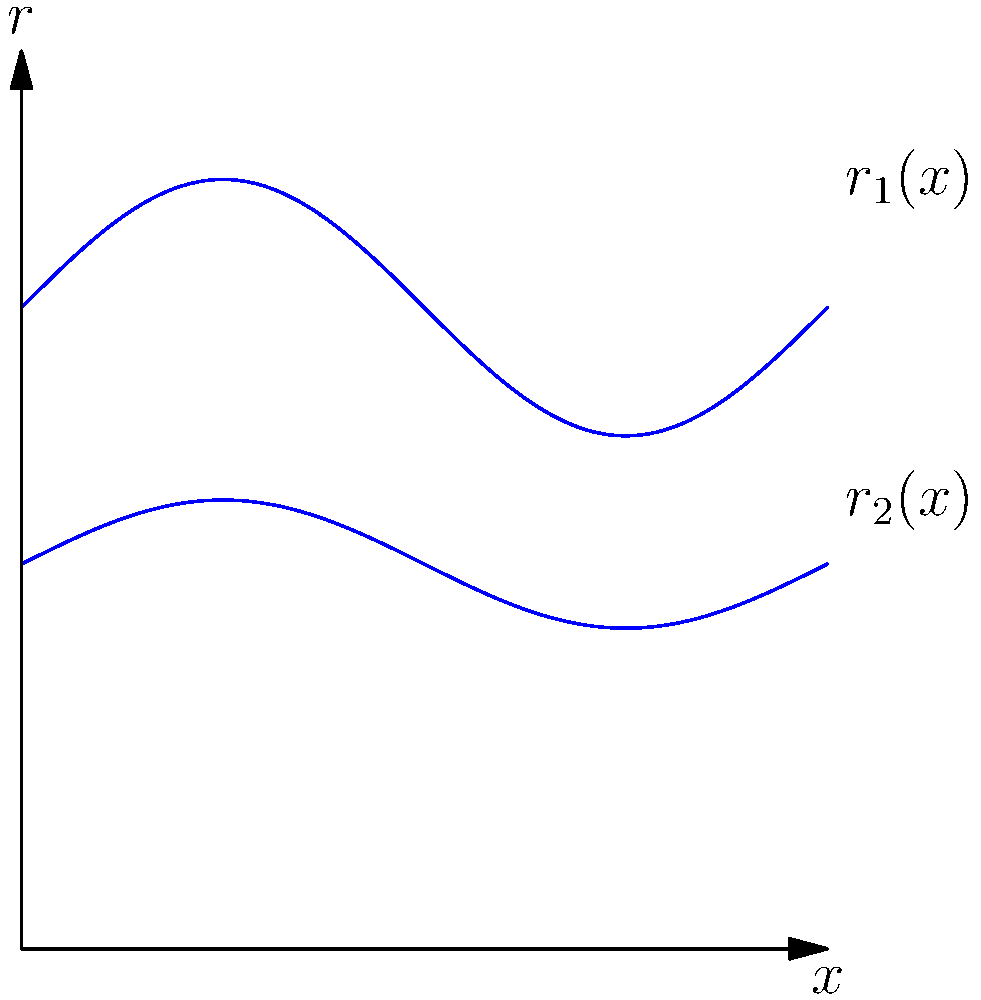A tubular polymer has an outer radius $r_1(x) = 5 + \sin(x)$ cm and an inner radius $r_2(x) = 3 + 0.5\sin(x)$ cm, where $x$ is the angle in radians along the circumference. Calculate the average cross-sectional area of the polymer tube over one complete revolution $(0 \leq x \leq 2\pi)$. To solve this problem, we'll follow these steps:

1) The cross-sectional area at any point $x$ is given by:
   $A(x) = \pi(r_1(x)^2 - r_2(x)^2)$

2) Substituting the given functions:
   $A(x) = \pi((5 + \sin(x))^2 - (3 + 0.5\sin(x))^2)$

3) To find the average area, we need to integrate this function over one revolution and divide by $2\pi$:

   $A_{avg} = \frac{1}{2\pi}\int_0^{2\pi} A(x) dx$

4) Expanding the integrand:
   $A(x) = \pi(25 + 10\sin(x) + \sin^2(x) - 9 - 3\sin(x) - 0.25\sin^2(x))$
   $     = \pi(16 + 7\sin(x) + 0.75\sin^2(x))$

5) Now, let's integrate each term:
   $\int_0^{2\pi} 16 dx = 32\pi$
   $\int_0^{2\pi} 7\sin(x) dx = 0$
   $\int_0^{2\pi} 0.75\sin^2(x) dx = 0.75\pi$

6) Sum these results:
   $\int_0^{2\pi} A(x) dx = \pi(32\pi + 0.75\pi) = 32.75\pi^2$

7) Finally, divide by $2\pi$ to get the average:
   $A_{avg} = \frac{32.75\pi^2}{2\pi} = 16.375\pi$ cm²
Answer: $16.375\pi$ cm² 